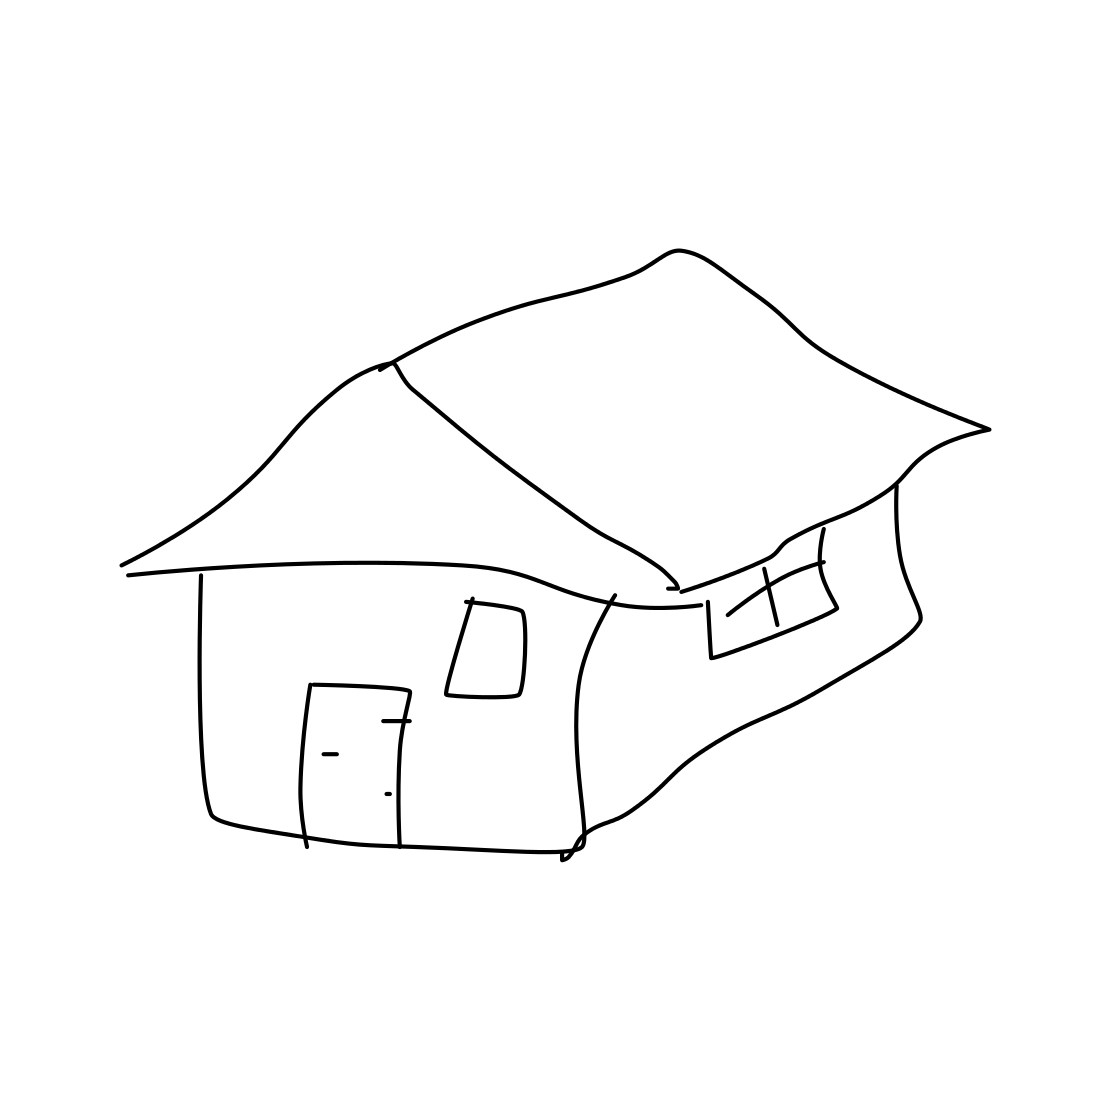What time of day does this house drawing seem to represent? The sketch does not provide clear indicators of a specific time of day, but the absence of dark shading or nighttime features might suggest it is intended to represent daylight hours. 